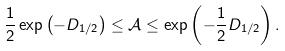Convert formula to latex. <formula><loc_0><loc_0><loc_500><loc_500>\frac { 1 } { 2 } \exp \left ( - D _ { 1 / 2 } \right ) \leq \mathcal { A } \leq \exp \left ( - \frac { 1 } { 2 } D _ { 1 / 2 } \right ) .</formula> 